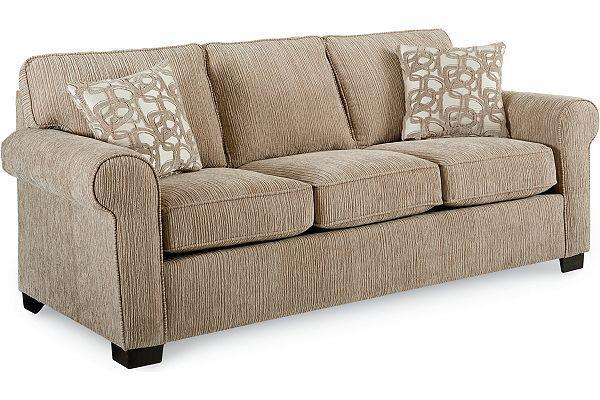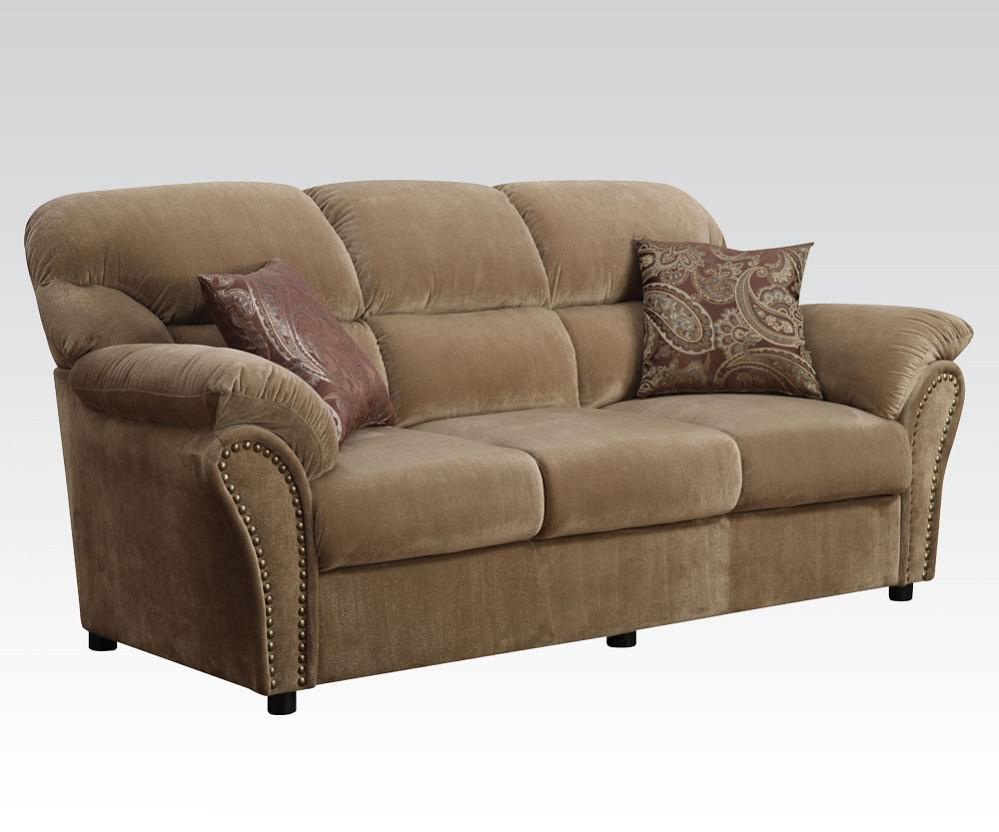The first image is the image on the left, the second image is the image on the right. Evaluate the accuracy of this statement regarding the images: "Each image features one diagonally-displayed three-cushion footed couch, with two matching patterned pillows positioned one on each end of the couch.". Is it true? Answer yes or no. Yes. The first image is the image on the left, the second image is the image on the right. For the images displayed, is the sentence "There are two throw pillows with different color circle patterns sitting on top of a sofa." factually correct? Answer yes or no. No. 